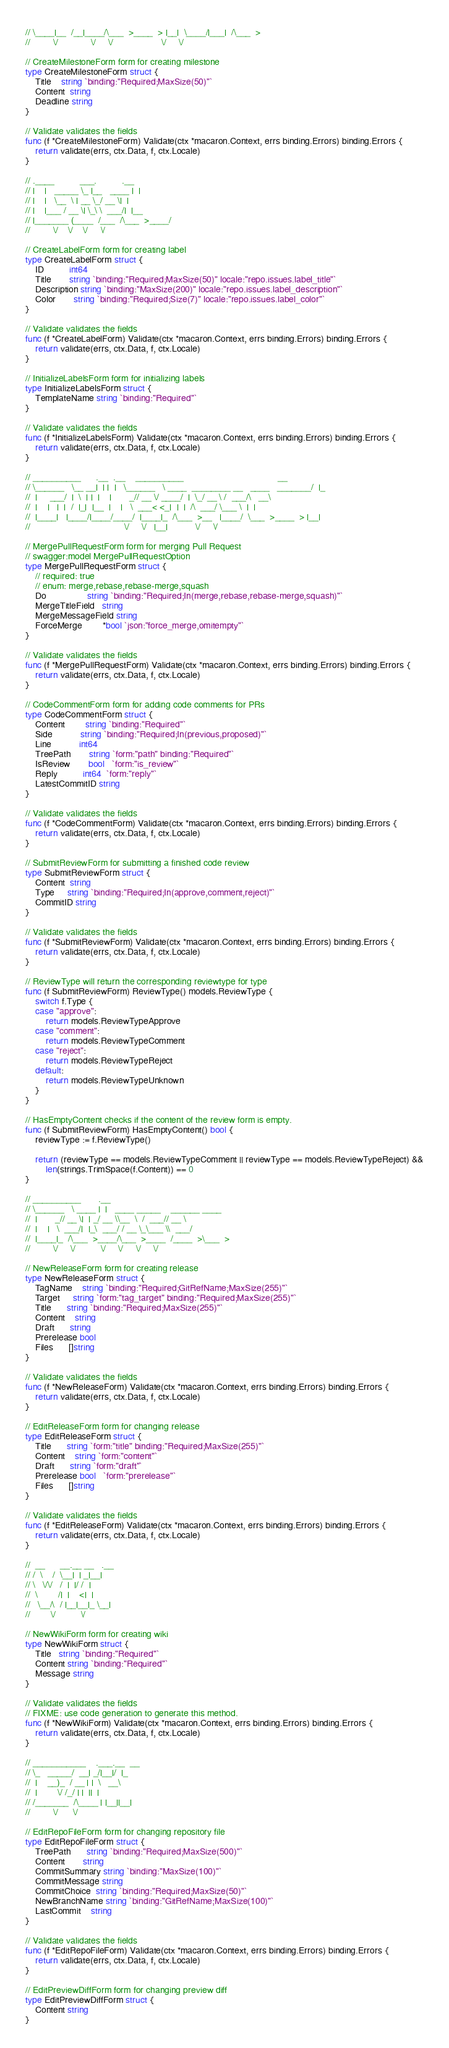<code> <loc_0><loc_0><loc_500><loc_500><_Go_>// \____|__  /__|____/\___  >____  > |__|  \____/|___|  /\___  >
//         \/             \/     \/                   \/     \/

// CreateMilestoneForm form for creating milestone
type CreateMilestoneForm struct {
	Title    string `binding:"Required;MaxSize(50)"`
	Content  string
	Deadline string
}

// Validate validates the fields
func (f *CreateMilestoneForm) Validate(ctx *macaron.Context, errs binding.Errors) binding.Errors {
	return validate(errs, ctx.Data, f, ctx.Locale)
}

// .____          ___.          .__
// |    |   _____ \_ |__   ____ |  |
// |    |   \__  \ | __ \_/ __ \|  |
// |    |___ / __ \| \_\ \  ___/|  |__
// |_______ (____  /___  /\___  >____/
//         \/    \/    \/     \/

// CreateLabelForm form for creating label
type CreateLabelForm struct {
	ID          int64
	Title       string `binding:"Required;MaxSize(50)" locale:"repo.issues.label_title"`
	Description string `binding:"MaxSize(200)" locale:"repo.issues.label_description"`
	Color       string `binding:"Required;Size(7)" locale:"repo.issues.label_color"`
}

// Validate validates the fields
func (f *CreateLabelForm) Validate(ctx *macaron.Context, errs binding.Errors) binding.Errors {
	return validate(errs, ctx.Data, f, ctx.Locale)
}

// InitializeLabelsForm form for initializing labels
type InitializeLabelsForm struct {
	TemplateName string `binding:"Required"`
}

// Validate validates the fields
func (f *InitializeLabelsForm) Validate(ctx *macaron.Context, errs binding.Errors) binding.Errors {
	return validate(errs, ctx.Data, f, ctx.Locale)
}

// __________      .__  .__    __________                                     __
// \______   \__ __|  | |  |   \______   \ ____  ________ __   ____   _______/  |_
//  |     ___/  |  \  | |  |    |       _// __ \/ ____/  |  \_/ __ \ /  ___/\   __\
//  |    |   |  |  /  |_|  |__  |    |   \  ___< <_|  |  |  /\  ___/ \___ \  |  |
//  |____|   |____/|____/____/  |____|_  /\___  >__   |____/  \___  >____  > |__|
//                                     \/     \/   |__|           \/     \/

// MergePullRequestForm form for merging Pull Request
// swagger:model MergePullRequestOption
type MergePullRequestForm struct {
	// required: true
	// enum: merge,rebase,rebase-merge,squash
	Do                string `binding:"Required;In(merge,rebase,rebase-merge,squash)"`
	MergeTitleField   string
	MergeMessageField string
	ForceMerge        *bool `json:"force_merge,omitempty"`
}

// Validate validates the fields
func (f *MergePullRequestForm) Validate(ctx *macaron.Context, errs binding.Errors) binding.Errors {
	return validate(errs, ctx.Data, f, ctx.Locale)
}

// CodeCommentForm form for adding code comments for PRs
type CodeCommentForm struct {
	Content        string `binding:"Required"`
	Side           string `binding:"Required;In(previous,proposed)"`
	Line           int64
	TreePath       string `form:"path" binding:"Required"`
	IsReview       bool   `form:"is_review"`
	Reply          int64  `form:"reply"`
	LatestCommitID string
}

// Validate validates the fields
func (f *CodeCommentForm) Validate(ctx *macaron.Context, errs binding.Errors) binding.Errors {
	return validate(errs, ctx.Data, f, ctx.Locale)
}

// SubmitReviewForm for submitting a finished code review
type SubmitReviewForm struct {
	Content  string
	Type     string `binding:"Required;In(approve,comment,reject)"`
	CommitID string
}

// Validate validates the fields
func (f *SubmitReviewForm) Validate(ctx *macaron.Context, errs binding.Errors) binding.Errors {
	return validate(errs, ctx.Data, f, ctx.Locale)
}

// ReviewType will return the corresponding reviewtype for type
func (f SubmitReviewForm) ReviewType() models.ReviewType {
	switch f.Type {
	case "approve":
		return models.ReviewTypeApprove
	case "comment":
		return models.ReviewTypeComment
	case "reject":
		return models.ReviewTypeReject
	default:
		return models.ReviewTypeUnknown
	}
}

// HasEmptyContent checks if the content of the review form is empty.
func (f SubmitReviewForm) HasEmptyContent() bool {
	reviewType := f.ReviewType()

	return (reviewType == models.ReviewTypeComment || reviewType == models.ReviewTypeReject) &&
		len(strings.TrimSpace(f.Content)) == 0
}

// __________       .__
// \______   \ ____ |  |   ____ _____    ______ ____
//  |       _// __ \|  | _/ __ \\__  \  /  ___// __ \
//  |    |   \  ___/|  |_\  ___/ / __ \_\___ \\  ___/
//  |____|_  /\___  >____/\___  >____  /____  >\___  >
//         \/     \/          \/     \/     \/     \/

// NewReleaseForm form for creating release
type NewReleaseForm struct {
	TagName    string `binding:"Required;GitRefName;MaxSize(255)"`
	Target     string `form:"tag_target" binding:"Required;MaxSize(255)"`
	Title      string `binding:"Required;MaxSize(255)"`
	Content    string
	Draft      string
	Prerelease bool
	Files      []string
}

// Validate validates the fields
func (f *NewReleaseForm) Validate(ctx *macaron.Context, errs binding.Errors) binding.Errors {
	return validate(errs, ctx.Data, f, ctx.Locale)
}

// EditReleaseForm form for changing release
type EditReleaseForm struct {
	Title      string `form:"title" binding:"Required;MaxSize(255)"`
	Content    string `form:"content"`
	Draft      string `form:"draft"`
	Prerelease bool   `form:"prerelease"`
	Files      []string
}

// Validate validates the fields
func (f *EditReleaseForm) Validate(ctx *macaron.Context, errs binding.Errors) binding.Errors {
	return validate(errs, ctx.Data, f, ctx.Locale)
}

//  __      __.__ __   .__
// /  \    /  \__|  | _|__|
// \   \/\/   /  |  |/ /  |
//  \        /|  |    <|  |
//   \__/\  / |__|__|_ \__|
//        \/          \/

// NewWikiForm form for creating wiki
type NewWikiForm struct {
	Title   string `binding:"Required"`
	Content string `binding:"Required"`
	Message string
}

// Validate validates the fields
// FIXME: use code generation to generate this method.
func (f *NewWikiForm) Validate(ctx *macaron.Context, errs binding.Errors) binding.Errors {
	return validate(errs, ctx.Data, f, ctx.Locale)
}

// ___________    .___.__  __
// \_   _____/  __| _/|__|/  |_
//  |    __)_  / __ | |  \   __\
//  |        \/ /_/ | |  ||  |
// /_______  /\____ | |__||__|
//         \/      \/

// EditRepoFileForm form for changing repository file
type EditRepoFileForm struct {
	TreePath      string `binding:"Required;MaxSize(500)"`
	Content       string
	CommitSummary string `binding:"MaxSize(100)"`
	CommitMessage string
	CommitChoice  string `binding:"Required;MaxSize(50)"`
	NewBranchName string `binding:"GitRefName;MaxSize(100)"`
	LastCommit    string
}

// Validate validates the fields
func (f *EditRepoFileForm) Validate(ctx *macaron.Context, errs binding.Errors) binding.Errors {
	return validate(errs, ctx.Data, f, ctx.Locale)
}

// EditPreviewDiffForm form for changing preview diff
type EditPreviewDiffForm struct {
	Content string
}
</code> 